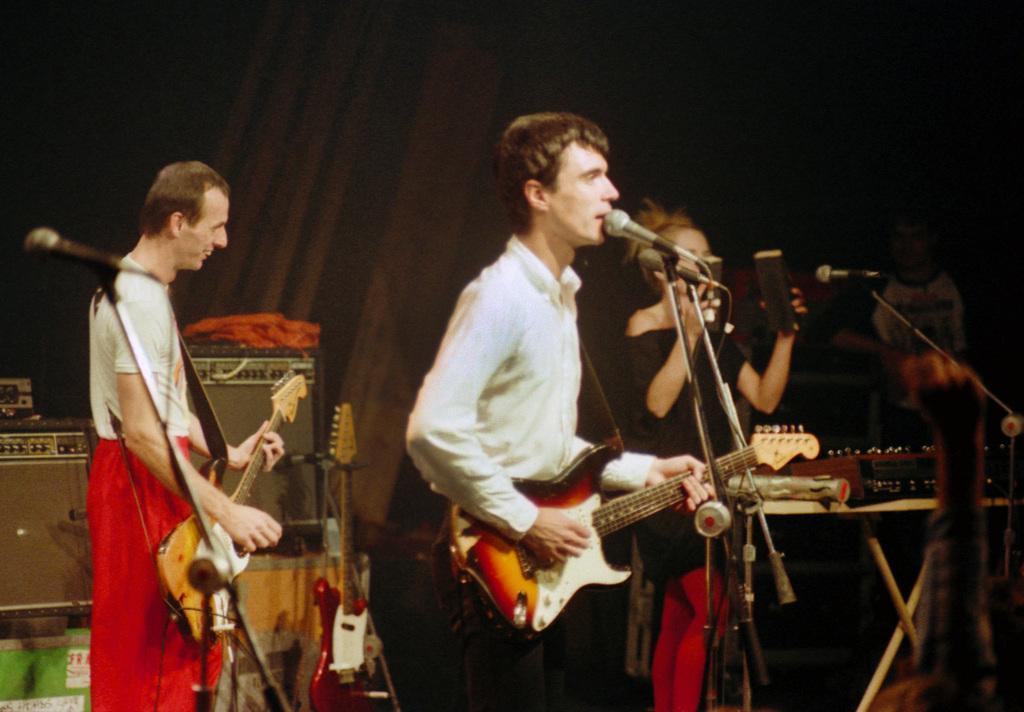Please provide a concise description of this image. In this image there are group of persons who are playing musical instruments. 